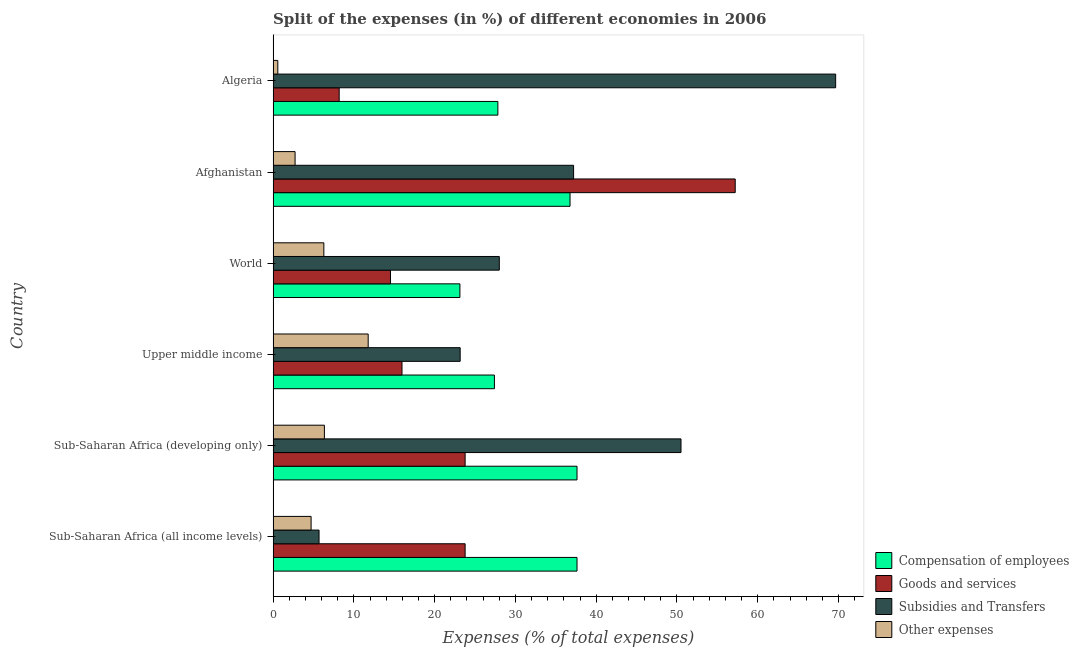How many different coloured bars are there?
Your answer should be compact. 4. How many groups of bars are there?
Your answer should be very brief. 6. Are the number of bars per tick equal to the number of legend labels?
Give a very brief answer. Yes. How many bars are there on the 6th tick from the bottom?
Your answer should be very brief. 4. What is the label of the 2nd group of bars from the top?
Offer a very short reply. Afghanistan. What is the percentage of amount spent on subsidies in Sub-Saharan Africa (all income levels)?
Give a very brief answer. 5.69. Across all countries, what is the maximum percentage of amount spent on goods and services?
Provide a succinct answer. 57.22. Across all countries, what is the minimum percentage of amount spent on compensation of employees?
Keep it short and to the point. 23.13. In which country was the percentage of amount spent on goods and services maximum?
Ensure brevity in your answer.  Afghanistan. In which country was the percentage of amount spent on goods and services minimum?
Your answer should be compact. Algeria. What is the total percentage of amount spent on other expenses in the graph?
Make the answer very short. 32.4. What is the difference between the percentage of amount spent on other expenses in Sub-Saharan Africa (developing only) and that in Upper middle income?
Your response must be concise. -5.42. What is the difference between the percentage of amount spent on subsidies in Sub-Saharan Africa (all income levels) and the percentage of amount spent on other expenses in Upper middle income?
Your response must be concise. -6.08. What is the average percentage of amount spent on compensation of employees per country?
Provide a short and direct response. 31.73. What is the difference between the percentage of amount spent on goods and services and percentage of amount spent on other expenses in Algeria?
Offer a terse response. 7.6. What is the ratio of the percentage of amount spent on goods and services in Algeria to that in World?
Your answer should be compact. 0.56. Is the percentage of amount spent on compensation of employees in Afghanistan less than that in Algeria?
Give a very brief answer. No. Is the difference between the percentage of amount spent on goods and services in Afghanistan and Upper middle income greater than the difference between the percentage of amount spent on compensation of employees in Afghanistan and Upper middle income?
Provide a succinct answer. Yes. What is the difference between the highest and the lowest percentage of amount spent on other expenses?
Ensure brevity in your answer.  11.19. In how many countries, is the percentage of amount spent on other expenses greater than the average percentage of amount spent on other expenses taken over all countries?
Provide a short and direct response. 3. Is the sum of the percentage of amount spent on goods and services in Algeria and Sub-Saharan Africa (all income levels) greater than the maximum percentage of amount spent on subsidies across all countries?
Provide a succinct answer. No. Is it the case that in every country, the sum of the percentage of amount spent on other expenses and percentage of amount spent on goods and services is greater than the sum of percentage of amount spent on compensation of employees and percentage of amount spent on subsidies?
Your answer should be compact. No. What does the 3rd bar from the top in Algeria represents?
Keep it short and to the point. Goods and services. What does the 1st bar from the bottom in Upper middle income represents?
Provide a short and direct response. Compensation of employees. Does the graph contain any zero values?
Ensure brevity in your answer.  No. Where does the legend appear in the graph?
Give a very brief answer. Bottom right. How many legend labels are there?
Make the answer very short. 4. How are the legend labels stacked?
Your response must be concise. Vertical. What is the title of the graph?
Provide a short and direct response. Split of the expenses (in %) of different economies in 2006. What is the label or title of the X-axis?
Your response must be concise. Expenses (% of total expenses). What is the Expenses (% of total expenses) of Compensation of employees in Sub-Saharan Africa (all income levels)?
Keep it short and to the point. 37.63. What is the Expenses (% of total expenses) in Goods and services in Sub-Saharan Africa (all income levels)?
Keep it short and to the point. 23.77. What is the Expenses (% of total expenses) in Subsidies and Transfers in Sub-Saharan Africa (all income levels)?
Your response must be concise. 5.69. What is the Expenses (% of total expenses) of Other expenses in Sub-Saharan Africa (all income levels)?
Your answer should be very brief. 4.7. What is the Expenses (% of total expenses) of Compensation of employees in Sub-Saharan Africa (developing only)?
Ensure brevity in your answer.  37.63. What is the Expenses (% of total expenses) in Goods and services in Sub-Saharan Africa (developing only)?
Your answer should be very brief. 23.77. What is the Expenses (% of total expenses) in Subsidies and Transfers in Sub-Saharan Africa (developing only)?
Offer a very short reply. 50.5. What is the Expenses (% of total expenses) in Other expenses in Sub-Saharan Africa (developing only)?
Provide a short and direct response. 6.35. What is the Expenses (% of total expenses) in Compensation of employees in Upper middle income?
Make the answer very short. 27.4. What is the Expenses (% of total expenses) in Goods and services in Upper middle income?
Provide a succinct answer. 15.96. What is the Expenses (% of total expenses) in Subsidies and Transfers in Upper middle income?
Your response must be concise. 23.16. What is the Expenses (% of total expenses) in Other expenses in Upper middle income?
Ensure brevity in your answer.  11.77. What is the Expenses (% of total expenses) in Compensation of employees in World?
Your answer should be compact. 23.13. What is the Expenses (% of total expenses) of Goods and services in World?
Your response must be concise. 14.53. What is the Expenses (% of total expenses) of Subsidies and Transfers in World?
Give a very brief answer. 28.01. What is the Expenses (% of total expenses) of Other expenses in World?
Offer a very short reply. 6.28. What is the Expenses (% of total expenses) of Compensation of employees in Afghanistan?
Ensure brevity in your answer.  36.76. What is the Expenses (% of total expenses) of Goods and services in Afghanistan?
Offer a very short reply. 57.22. What is the Expenses (% of total expenses) in Subsidies and Transfers in Afghanistan?
Provide a short and direct response. 37.2. What is the Expenses (% of total expenses) in Other expenses in Afghanistan?
Your answer should be very brief. 2.72. What is the Expenses (% of total expenses) in Compensation of employees in Algeria?
Make the answer very short. 27.83. What is the Expenses (% of total expenses) in Goods and services in Algeria?
Provide a succinct answer. 8.18. What is the Expenses (% of total expenses) in Subsidies and Transfers in Algeria?
Offer a very short reply. 69.65. What is the Expenses (% of total expenses) in Other expenses in Algeria?
Keep it short and to the point. 0.58. Across all countries, what is the maximum Expenses (% of total expenses) of Compensation of employees?
Offer a very short reply. 37.63. Across all countries, what is the maximum Expenses (% of total expenses) in Goods and services?
Make the answer very short. 57.22. Across all countries, what is the maximum Expenses (% of total expenses) of Subsidies and Transfers?
Ensure brevity in your answer.  69.65. Across all countries, what is the maximum Expenses (% of total expenses) of Other expenses?
Provide a succinct answer. 11.77. Across all countries, what is the minimum Expenses (% of total expenses) of Compensation of employees?
Offer a terse response. 23.13. Across all countries, what is the minimum Expenses (% of total expenses) in Goods and services?
Your answer should be compact. 8.18. Across all countries, what is the minimum Expenses (% of total expenses) in Subsidies and Transfers?
Give a very brief answer. 5.69. Across all countries, what is the minimum Expenses (% of total expenses) of Other expenses?
Make the answer very short. 0.58. What is the total Expenses (% of total expenses) of Compensation of employees in the graph?
Ensure brevity in your answer.  190.38. What is the total Expenses (% of total expenses) of Goods and services in the graph?
Offer a terse response. 143.44. What is the total Expenses (% of total expenses) of Subsidies and Transfers in the graph?
Offer a very short reply. 214.22. What is the total Expenses (% of total expenses) of Other expenses in the graph?
Provide a short and direct response. 32.4. What is the difference between the Expenses (% of total expenses) in Compensation of employees in Sub-Saharan Africa (all income levels) and that in Sub-Saharan Africa (developing only)?
Your response must be concise. 0. What is the difference between the Expenses (% of total expenses) in Subsidies and Transfers in Sub-Saharan Africa (all income levels) and that in Sub-Saharan Africa (developing only)?
Your answer should be very brief. -44.82. What is the difference between the Expenses (% of total expenses) of Other expenses in Sub-Saharan Africa (all income levels) and that in Sub-Saharan Africa (developing only)?
Your answer should be compact. -1.65. What is the difference between the Expenses (% of total expenses) in Compensation of employees in Sub-Saharan Africa (all income levels) and that in Upper middle income?
Provide a succinct answer. 10.23. What is the difference between the Expenses (% of total expenses) of Goods and services in Sub-Saharan Africa (all income levels) and that in Upper middle income?
Your response must be concise. 7.82. What is the difference between the Expenses (% of total expenses) of Subsidies and Transfers in Sub-Saharan Africa (all income levels) and that in Upper middle income?
Offer a very short reply. -17.47. What is the difference between the Expenses (% of total expenses) in Other expenses in Sub-Saharan Africa (all income levels) and that in Upper middle income?
Make the answer very short. -7.07. What is the difference between the Expenses (% of total expenses) of Compensation of employees in Sub-Saharan Africa (all income levels) and that in World?
Your answer should be compact. 14.5. What is the difference between the Expenses (% of total expenses) of Goods and services in Sub-Saharan Africa (all income levels) and that in World?
Your answer should be compact. 9.24. What is the difference between the Expenses (% of total expenses) in Subsidies and Transfers in Sub-Saharan Africa (all income levels) and that in World?
Provide a succinct answer. -22.32. What is the difference between the Expenses (% of total expenses) in Other expenses in Sub-Saharan Africa (all income levels) and that in World?
Keep it short and to the point. -1.58. What is the difference between the Expenses (% of total expenses) of Compensation of employees in Sub-Saharan Africa (all income levels) and that in Afghanistan?
Make the answer very short. 0.86. What is the difference between the Expenses (% of total expenses) of Goods and services in Sub-Saharan Africa (all income levels) and that in Afghanistan?
Your answer should be very brief. -33.44. What is the difference between the Expenses (% of total expenses) in Subsidies and Transfers in Sub-Saharan Africa (all income levels) and that in Afghanistan?
Offer a terse response. -31.52. What is the difference between the Expenses (% of total expenses) of Other expenses in Sub-Saharan Africa (all income levels) and that in Afghanistan?
Give a very brief answer. 1.98. What is the difference between the Expenses (% of total expenses) of Compensation of employees in Sub-Saharan Africa (all income levels) and that in Algeria?
Provide a succinct answer. 9.8. What is the difference between the Expenses (% of total expenses) of Goods and services in Sub-Saharan Africa (all income levels) and that in Algeria?
Give a very brief answer. 15.59. What is the difference between the Expenses (% of total expenses) of Subsidies and Transfers in Sub-Saharan Africa (all income levels) and that in Algeria?
Offer a very short reply. -63.97. What is the difference between the Expenses (% of total expenses) of Other expenses in Sub-Saharan Africa (all income levels) and that in Algeria?
Your answer should be compact. 4.12. What is the difference between the Expenses (% of total expenses) in Compensation of employees in Sub-Saharan Africa (developing only) and that in Upper middle income?
Ensure brevity in your answer.  10.23. What is the difference between the Expenses (% of total expenses) of Goods and services in Sub-Saharan Africa (developing only) and that in Upper middle income?
Your response must be concise. 7.82. What is the difference between the Expenses (% of total expenses) of Subsidies and Transfers in Sub-Saharan Africa (developing only) and that in Upper middle income?
Provide a succinct answer. 27.34. What is the difference between the Expenses (% of total expenses) in Other expenses in Sub-Saharan Africa (developing only) and that in Upper middle income?
Ensure brevity in your answer.  -5.42. What is the difference between the Expenses (% of total expenses) of Compensation of employees in Sub-Saharan Africa (developing only) and that in World?
Give a very brief answer. 14.5. What is the difference between the Expenses (% of total expenses) in Goods and services in Sub-Saharan Africa (developing only) and that in World?
Your response must be concise. 9.24. What is the difference between the Expenses (% of total expenses) of Subsidies and Transfers in Sub-Saharan Africa (developing only) and that in World?
Make the answer very short. 22.5. What is the difference between the Expenses (% of total expenses) of Other expenses in Sub-Saharan Africa (developing only) and that in World?
Your response must be concise. 0.07. What is the difference between the Expenses (% of total expenses) in Compensation of employees in Sub-Saharan Africa (developing only) and that in Afghanistan?
Your answer should be compact. 0.86. What is the difference between the Expenses (% of total expenses) in Goods and services in Sub-Saharan Africa (developing only) and that in Afghanistan?
Offer a terse response. -33.44. What is the difference between the Expenses (% of total expenses) in Subsidies and Transfers in Sub-Saharan Africa (developing only) and that in Afghanistan?
Keep it short and to the point. 13.3. What is the difference between the Expenses (% of total expenses) in Other expenses in Sub-Saharan Africa (developing only) and that in Afghanistan?
Keep it short and to the point. 3.63. What is the difference between the Expenses (% of total expenses) in Compensation of employees in Sub-Saharan Africa (developing only) and that in Algeria?
Your answer should be compact. 9.8. What is the difference between the Expenses (% of total expenses) of Goods and services in Sub-Saharan Africa (developing only) and that in Algeria?
Offer a terse response. 15.59. What is the difference between the Expenses (% of total expenses) in Subsidies and Transfers in Sub-Saharan Africa (developing only) and that in Algeria?
Your response must be concise. -19.15. What is the difference between the Expenses (% of total expenses) in Other expenses in Sub-Saharan Africa (developing only) and that in Algeria?
Your answer should be very brief. 5.77. What is the difference between the Expenses (% of total expenses) of Compensation of employees in Upper middle income and that in World?
Ensure brevity in your answer.  4.27. What is the difference between the Expenses (% of total expenses) of Goods and services in Upper middle income and that in World?
Give a very brief answer. 1.43. What is the difference between the Expenses (% of total expenses) of Subsidies and Transfers in Upper middle income and that in World?
Your answer should be very brief. -4.85. What is the difference between the Expenses (% of total expenses) in Other expenses in Upper middle income and that in World?
Provide a short and direct response. 5.49. What is the difference between the Expenses (% of total expenses) in Compensation of employees in Upper middle income and that in Afghanistan?
Provide a succinct answer. -9.36. What is the difference between the Expenses (% of total expenses) of Goods and services in Upper middle income and that in Afghanistan?
Your answer should be compact. -41.26. What is the difference between the Expenses (% of total expenses) of Subsidies and Transfers in Upper middle income and that in Afghanistan?
Provide a short and direct response. -14.04. What is the difference between the Expenses (% of total expenses) of Other expenses in Upper middle income and that in Afghanistan?
Ensure brevity in your answer.  9.05. What is the difference between the Expenses (% of total expenses) in Compensation of employees in Upper middle income and that in Algeria?
Your answer should be very brief. -0.43. What is the difference between the Expenses (% of total expenses) in Goods and services in Upper middle income and that in Algeria?
Your response must be concise. 7.78. What is the difference between the Expenses (% of total expenses) in Subsidies and Transfers in Upper middle income and that in Algeria?
Keep it short and to the point. -46.49. What is the difference between the Expenses (% of total expenses) of Other expenses in Upper middle income and that in Algeria?
Provide a succinct answer. 11.19. What is the difference between the Expenses (% of total expenses) of Compensation of employees in World and that in Afghanistan?
Ensure brevity in your answer.  -13.64. What is the difference between the Expenses (% of total expenses) in Goods and services in World and that in Afghanistan?
Make the answer very short. -42.68. What is the difference between the Expenses (% of total expenses) in Subsidies and Transfers in World and that in Afghanistan?
Your answer should be very brief. -9.2. What is the difference between the Expenses (% of total expenses) in Other expenses in World and that in Afghanistan?
Your answer should be compact. 3.56. What is the difference between the Expenses (% of total expenses) of Compensation of employees in World and that in Algeria?
Offer a very short reply. -4.7. What is the difference between the Expenses (% of total expenses) of Goods and services in World and that in Algeria?
Your answer should be compact. 6.35. What is the difference between the Expenses (% of total expenses) in Subsidies and Transfers in World and that in Algeria?
Provide a succinct answer. -41.65. What is the difference between the Expenses (% of total expenses) in Other expenses in World and that in Algeria?
Make the answer very short. 5.7. What is the difference between the Expenses (% of total expenses) in Compensation of employees in Afghanistan and that in Algeria?
Your answer should be very brief. 8.93. What is the difference between the Expenses (% of total expenses) of Goods and services in Afghanistan and that in Algeria?
Provide a short and direct response. 49.04. What is the difference between the Expenses (% of total expenses) of Subsidies and Transfers in Afghanistan and that in Algeria?
Offer a very short reply. -32.45. What is the difference between the Expenses (% of total expenses) in Other expenses in Afghanistan and that in Algeria?
Keep it short and to the point. 2.14. What is the difference between the Expenses (% of total expenses) of Compensation of employees in Sub-Saharan Africa (all income levels) and the Expenses (% of total expenses) of Goods and services in Sub-Saharan Africa (developing only)?
Your answer should be very brief. 13.85. What is the difference between the Expenses (% of total expenses) in Compensation of employees in Sub-Saharan Africa (all income levels) and the Expenses (% of total expenses) in Subsidies and Transfers in Sub-Saharan Africa (developing only)?
Provide a short and direct response. -12.88. What is the difference between the Expenses (% of total expenses) of Compensation of employees in Sub-Saharan Africa (all income levels) and the Expenses (% of total expenses) of Other expenses in Sub-Saharan Africa (developing only)?
Your answer should be very brief. 31.28. What is the difference between the Expenses (% of total expenses) of Goods and services in Sub-Saharan Africa (all income levels) and the Expenses (% of total expenses) of Subsidies and Transfers in Sub-Saharan Africa (developing only)?
Keep it short and to the point. -26.73. What is the difference between the Expenses (% of total expenses) in Goods and services in Sub-Saharan Africa (all income levels) and the Expenses (% of total expenses) in Other expenses in Sub-Saharan Africa (developing only)?
Provide a succinct answer. 17.43. What is the difference between the Expenses (% of total expenses) in Subsidies and Transfers in Sub-Saharan Africa (all income levels) and the Expenses (% of total expenses) in Other expenses in Sub-Saharan Africa (developing only)?
Your answer should be compact. -0.66. What is the difference between the Expenses (% of total expenses) of Compensation of employees in Sub-Saharan Africa (all income levels) and the Expenses (% of total expenses) of Goods and services in Upper middle income?
Offer a very short reply. 21.67. What is the difference between the Expenses (% of total expenses) of Compensation of employees in Sub-Saharan Africa (all income levels) and the Expenses (% of total expenses) of Subsidies and Transfers in Upper middle income?
Make the answer very short. 14.47. What is the difference between the Expenses (% of total expenses) of Compensation of employees in Sub-Saharan Africa (all income levels) and the Expenses (% of total expenses) of Other expenses in Upper middle income?
Your response must be concise. 25.86. What is the difference between the Expenses (% of total expenses) in Goods and services in Sub-Saharan Africa (all income levels) and the Expenses (% of total expenses) in Subsidies and Transfers in Upper middle income?
Give a very brief answer. 0.61. What is the difference between the Expenses (% of total expenses) of Goods and services in Sub-Saharan Africa (all income levels) and the Expenses (% of total expenses) of Other expenses in Upper middle income?
Give a very brief answer. 12. What is the difference between the Expenses (% of total expenses) in Subsidies and Transfers in Sub-Saharan Africa (all income levels) and the Expenses (% of total expenses) in Other expenses in Upper middle income?
Offer a very short reply. -6.08. What is the difference between the Expenses (% of total expenses) of Compensation of employees in Sub-Saharan Africa (all income levels) and the Expenses (% of total expenses) of Goods and services in World?
Make the answer very short. 23.1. What is the difference between the Expenses (% of total expenses) of Compensation of employees in Sub-Saharan Africa (all income levels) and the Expenses (% of total expenses) of Subsidies and Transfers in World?
Offer a terse response. 9.62. What is the difference between the Expenses (% of total expenses) of Compensation of employees in Sub-Saharan Africa (all income levels) and the Expenses (% of total expenses) of Other expenses in World?
Your answer should be compact. 31.35. What is the difference between the Expenses (% of total expenses) in Goods and services in Sub-Saharan Africa (all income levels) and the Expenses (% of total expenses) in Subsidies and Transfers in World?
Provide a succinct answer. -4.23. What is the difference between the Expenses (% of total expenses) of Goods and services in Sub-Saharan Africa (all income levels) and the Expenses (% of total expenses) of Other expenses in World?
Offer a very short reply. 17.49. What is the difference between the Expenses (% of total expenses) of Subsidies and Transfers in Sub-Saharan Africa (all income levels) and the Expenses (% of total expenses) of Other expenses in World?
Make the answer very short. -0.59. What is the difference between the Expenses (% of total expenses) of Compensation of employees in Sub-Saharan Africa (all income levels) and the Expenses (% of total expenses) of Goods and services in Afghanistan?
Ensure brevity in your answer.  -19.59. What is the difference between the Expenses (% of total expenses) of Compensation of employees in Sub-Saharan Africa (all income levels) and the Expenses (% of total expenses) of Subsidies and Transfers in Afghanistan?
Provide a succinct answer. 0.42. What is the difference between the Expenses (% of total expenses) in Compensation of employees in Sub-Saharan Africa (all income levels) and the Expenses (% of total expenses) in Other expenses in Afghanistan?
Your answer should be very brief. 34.91. What is the difference between the Expenses (% of total expenses) of Goods and services in Sub-Saharan Africa (all income levels) and the Expenses (% of total expenses) of Subsidies and Transfers in Afghanistan?
Provide a short and direct response. -13.43. What is the difference between the Expenses (% of total expenses) of Goods and services in Sub-Saharan Africa (all income levels) and the Expenses (% of total expenses) of Other expenses in Afghanistan?
Your answer should be compact. 21.06. What is the difference between the Expenses (% of total expenses) of Subsidies and Transfers in Sub-Saharan Africa (all income levels) and the Expenses (% of total expenses) of Other expenses in Afghanistan?
Your answer should be very brief. 2.97. What is the difference between the Expenses (% of total expenses) in Compensation of employees in Sub-Saharan Africa (all income levels) and the Expenses (% of total expenses) in Goods and services in Algeria?
Offer a terse response. 29.45. What is the difference between the Expenses (% of total expenses) in Compensation of employees in Sub-Saharan Africa (all income levels) and the Expenses (% of total expenses) in Subsidies and Transfers in Algeria?
Your answer should be compact. -32.03. What is the difference between the Expenses (% of total expenses) in Compensation of employees in Sub-Saharan Africa (all income levels) and the Expenses (% of total expenses) in Other expenses in Algeria?
Your answer should be very brief. 37.05. What is the difference between the Expenses (% of total expenses) in Goods and services in Sub-Saharan Africa (all income levels) and the Expenses (% of total expenses) in Subsidies and Transfers in Algeria?
Offer a terse response. -45.88. What is the difference between the Expenses (% of total expenses) of Goods and services in Sub-Saharan Africa (all income levels) and the Expenses (% of total expenses) of Other expenses in Algeria?
Ensure brevity in your answer.  23.19. What is the difference between the Expenses (% of total expenses) in Subsidies and Transfers in Sub-Saharan Africa (all income levels) and the Expenses (% of total expenses) in Other expenses in Algeria?
Your response must be concise. 5.11. What is the difference between the Expenses (% of total expenses) of Compensation of employees in Sub-Saharan Africa (developing only) and the Expenses (% of total expenses) of Goods and services in Upper middle income?
Provide a short and direct response. 21.67. What is the difference between the Expenses (% of total expenses) of Compensation of employees in Sub-Saharan Africa (developing only) and the Expenses (% of total expenses) of Subsidies and Transfers in Upper middle income?
Give a very brief answer. 14.47. What is the difference between the Expenses (% of total expenses) in Compensation of employees in Sub-Saharan Africa (developing only) and the Expenses (% of total expenses) in Other expenses in Upper middle income?
Offer a terse response. 25.86. What is the difference between the Expenses (% of total expenses) of Goods and services in Sub-Saharan Africa (developing only) and the Expenses (% of total expenses) of Subsidies and Transfers in Upper middle income?
Your answer should be compact. 0.61. What is the difference between the Expenses (% of total expenses) in Goods and services in Sub-Saharan Africa (developing only) and the Expenses (% of total expenses) in Other expenses in Upper middle income?
Your answer should be very brief. 12. What is the difference between the Expenses (% of total expenses) of Subsidies and Transfers in Sub-Saharan Africa (developing only) and the Expenses (% of total expenses) of Other expenses in Upper middle income?
Provide a succinct answer. 38.73. What is the difference between the Expenses (% of total expenses) in Compensation of employees in Sub-Saharan Africa (developing only) and the Expenses (% of total expenses) in Goods and services in World?
Offer a terse response. 23.1. What is the difference between the Expenses (% of total expenses) in Compensation of employees in Sub-Saharan Africa (developing only) and the Expenses (% of total expenses) in Subsidies and Transfers in World?
Offer a very short reply. 9.62. What is the difference between the Expenses (% of total expenses) in Compensation of employees in Sub-Saharan Africa (developing only) and the Expenses (% of total expenses) in Other expenses in World?
Give a very brief answer. 31.35. What is the difference between the Expenses (% of total expenses) of Goods and services in Sub-Saharan Africa (developing only) and the Expenses (% of total expenses) of Subsidies and Transfers in World?
Ensure brevity in your answer.  -4.23. What is the difference between the Expenses (% of total expenses) of Goods and services in Sub-Saharan Africa (developing only) and the Expenses (% of total expenses) of Other expenses in World?
Keep it short and to the point. 17.49. What is the difference between the Expenses (% of total expenses) of Subsidies and Transfers in Sub-Saharan Africa (developing only) and the Expenses (% of total expenses) of Other expenses in World?
Ensure brevity in your answer.  44.22. What is the difference between the Expenses (% of total expenses) of Compensation of employees in Sub-Saharan Africa (developing only) and the Expenses (% of total expenses) of Goods and services in Afghanistan?
Ensure brevity in your answer.  -19.59. What is the difference between the Expenses (% of total expenses) of Compensation of employees in Sub-Saharan Africa (developing only) and the Expenses (% of total expenses) of Subsidies and Transfers in Afghanistan?
Keep it short and to the point. 0.42. What is the difference between the Expenses (% of total expenses) of Compensation of employees in Sub-Saharan Africa (developing only) and the Expenses (% of total expenses) of Other expenses in Afghanistan?
Your answer should be compact. 34.91. What is the difference between the Expenses (% of total expenses) in Goods and services in Sub-Saharan Africa (developing only) and the Expenses (% of total expenses) in Subsidies and Transfers in Afghanistan?
Your answer should be compact. -13.43. What is the difference between the Expenses (% of total expenses) in Goods and services in Sub-Saharan Africa (developing only) and the Expenses (% of total expenses) in Other expenses in Afghanistan?
Ensure brevity in your answer.  21.06. What is the difference between the Expenses (% of total expenses) of Subsidies and Transfers in Sub-Saharan Africa (developing only) and the Expenses (% of total expenses) of Other expenses in Afghanistan?
Provide a short and direct response. 47.79. What is the difference between the Expenses (% of total expenses) of Compensation of employees in Sub-Saharan Africa (developing only) and the Expenses (% of total expenses) of Goods and services in Algeria?
Keep it short and to the point. 29.45. What is the difference between the Expenses (% of total expenses) of Compensation of employees in Sub-Saharan Africa (developing only) and the Expenses (% of total expenses) of Subsidies and Transfers in Algeria?
Offer a terse response. -32.03. What is the difference between the Expenses (% of total expenses) of Compensation of employees in Sub-Saharan Africa (developing only) and the Expenses (% of total expenses) of Other expenses in Algeria?
Provide a succinct answer. 37.05. What is the difference between the Expenses (% of total expenses) in Goods and services in Sub-Saharan Africa (developing only) and the Expenses (% of total expenses) in Subsidies and Transfers in Algeria?
Ensure brevity in your answer.  -45.88. What is the difference between the Expenses (% of total expenses) of Goods and services in Sub-Saharan Africa (developing only) and the Expenses (% of total expenses) of Other expenses in Algeria?
Your response must be concise. 23.19. What is the difference between the Expenses (% of total expenses) of Subsidies and Transfers in Sub-Saharan Africa (developing only) and the Expenses (% of total expenses) of Other expenses in Algeria?
Make the answer very short. 49.92. What is the difference between the Expenses (% of total expenses) of Compensation of employees in Upper middle income and the Expenses (% of total expenses) of Goods and services in World?
Offer a very short reply. 12.87. What is the difference between the Expenses (% of total expenses) of Compensation of employees in Upper middle income and the Expenses (% of total expenses) of Subsidies and Transfers in World?
Keep it short and to the point. -0.61. What is the difference between the Expenses (% of total expenses) in Compensation of employees in Upper middle income and the Expenses (% of total expenses) in Other expenses in World?
Make the answer very short. 21.12. What is the difference between the Expenses (% of total expenses) of Goods and services in Upper middle income and the Expenses (% of total expenses) of Subsidies and Transfers in World?
Keep it short and to the point. -12.05. What is the difference between the Expenses (% of total expenses) in Goods and services in Upper middle income and the Expenses (% of total expenses) in Other expenses in World?
Give a very brief answer. 9.68. What is the difference between the Expenses (% of total expenses) of Subsidies and Transfers in Upper middle income and the Expenses (% of total expenses) of Other expenses in World?
Provide a short and direct response. 16.88. What is the difference between the Expenses (% of total expenses) of Compensation of employees in Upper middle income and the Expenses (% of total expenses) of Goods and services in Afghanistan?
Give a very brief answer. -29.82. What is the difference between the Expenses (% of total expenses) in Compensation of employees in Upper middle income and the Expenses (% of total expenses) in Subsidies and Transfers in Afghanistan?
Ensure brevity in your answer.  -9.8. What is the difference between the Expenses (% of total expenses) in Compensation of employees in Upper middle income and the Expenses (% of total expenses) in Other expenses in Afghanistan?
Give a very brief answer. 24.68. What is the difference between the Expenses (% of total expenses) in Goods and services in Upper middle income and the Expenses (% of total expenses) in Subsidies and Transfers in Afghanistan?
Provide a short and direct response. -21.25. What is the difference between the Expenses (% of total expenses) in Goods and services in Upper middle income and the Expenses (% of total expenses) in Other expenses in Afghanistan?
Make the answer very short. 13.24. What is the difference between the Expenses (% of total expenses) in Subsidies and Transfers in Upper middle income and the Expenses (% of total expenses) in Other expenses in Afghanistan?
Provide a succinct answer. 20.44. What is the difference between the Expenses (% of total expenses) of Compensation of employees in Upper middle income and the Expenses (% of total expenses) of Goods and services in Algeria?
Your answer should be compact. 19.22. What is the difference between the Expenses (% of total expenses) in Compensation of employees in Upper middle income and the Expenses (% of total expenses) in Subsidies and Transfers in Algeria?
Make the answer very short. -42.25. What is the difference between the Expenses (% of total expenses) of Compensation of employees in Upper middle income and the Expenses (% of total expenses) of Other expenses in Algeria?
Give a very brief answer. 26.82. What is the difference between the Expenses (% of total expenses) of Goods and services in Upper middle income and the Expenses (% of total expenses) of Subsidies and Transfers in Algeria?
Provide a succinct answer. -53.7. What is the difference between the Expenses (% of total expenses) of Goods and services in Upper middle income and the Expenses (% of total expenses) of Other expenses in Algeria?
Provide a succinct answer. 15.38. What is the difference between the Expenses (% of total expenses) of Subsidies and Transfers in Upper middle income and the Expenses (% of total expenses) of Other expenses in Algeria?
Your answer should be very brief. 22.58. What is the difference between the Expenses (% of total expenses) in Compensation of employees in World and the Expenses (% of total expenses) in Goods and services in Afghanistan?
Make the answer very short. -34.09. What is the difference between the Expenses (% of total expenses) in Compensation of employees in World and the Expenses (% of total expenses) in Subsidies and Transfers in Afghanistan?
Offer a terse response. -14.08. What is the difference between the Expenses (% of total expenses) in Compensation of employees in World and the Expenses (% of total expenses) in Other expenses in Afghanistan?
Give a very brief answer. 20.41. What is the difference between the Expenses (% of total expenses) of Goods and services in World and the Expenses (% of total expenses) of Subsidies and Transfers in Afghanistan?
Ensure brevity in your answer.  -22.67. What is the difference between the Expenses (% of total expenses) of Goods and services in World and the Expenses (% of total expenses) of Other expenses in Afghanistan?
Make the answer very short. 11.81. What is the difference between the Expenses (% of total expenses) in Subsidies and Transfers in World and the Expenses (% of total expenses) in Other expenses in Afghanistan?
Your response must be concise. 25.29. What is the difference between the Expenses (% of total expenses) of Compensation of employees in World and the Expenses (% of total expenses) of Goods and services in Algeria?
Offer a very short reply. 14.95. What is the difference between the Expenses (% of total expenses) in Compensation of employees in World and the Expenses (% of total expenses) in Subsidies and Transfers in Algeria?
Your answer should be very brief. -46.53. What is the difference between the Expenses (% of total expenses) of Compensation of employees in World and the Expenses (% of total expenses) of Other expenses in Algeria?
Keep it short and to the point. 22.55. What is the difference between the Expenses (% of total expenses) in Goods and services in World and the Expenses (% of total expenses) in Subsidies and Transfers in Algeria?
Your answer should be compact. -55.12. What is the difference between the Expenses (% of total expenses) in Goods and services in World and the Expenses (% of total expenses) in Other expenses in Algeria?
Give a very brief answer. 13.95. What is the difference between the Expenses (% of total expenses) of Subsidies and Transfers in World and the Expenses (% of total expenses) of Other expenses in Algeria?
Make the answer very short. 27.43. What is the difference between the Expenses (% of total expenses) of Compensation of employees in Afghanistan and the Expenses (% of total expenses) of Goods and services in Algeria?
Keep it short and to the point. 28.58. What is the difference between the Expenses (% of total expenses) in Compensation of employees in Afghanistan and the Expenses (% of total expenses) in Subsidies and Transfers in Algeria?
Keep it short and to the point. -32.89. What is the difference between the Expenses (% of total expenses) of Compensation of employees in Afghanistan and the Expenses (% of total expenses) of Other expenses in Algeria?
Your answer should be very brief. 36.18. What is the difference between the Expenses (% of total expenses) of Goods and services in Afghanistan and the Expenses (% of total expenses) of Subsidies and Transfers in Algeria?
Provide a succinct answer. -12.44. What is the difference between the Expenses (% of total expenses) in Goods and services in Afghanistan and the Expenses (% of total expenses) in Other expenses in Algeria?
Your response must be concise. 56.63. What is the difference between the Expenses (% of total expenses) in Subsidies and Transfers in Afghanistan and the Expenses (% of total expenses) in Other expenses in Algeria?
Provide a short and direct response. 36.62. What is the average Expenses (% of total expenses) of Compensation of employees per country?
Give a very brief answer. 31.73. What is the average Expenses (% of total expenses) in Goods and services per country?
Your answer should be very brief. 23.91. What is the average Expenses (% of total expenses) in Subsidies and Transfers per country?
Offer a terse response. 35.7. What is the average Expenses (% of total expenses) in Other expenses per country?
Make the answer very short. 5.4. What is the difference between the Expenses (% of total expenses) in Compensation of employees and Expenses (% of total expenses) in Goods and services in Sub-Saharan Africa (all income levels)?
Your answer should be very brief. 13.85. What is the difference between the Expenses (% of total expenses) of Compensation of employees and Expenses (% of total expenses) of Subsidies and Transfers in Sub-Saharan Africa (all income levels)?
Provide a short and direct response. 31.94. What is the difference between the Expenses (% of total expenses) in Compensation of employees and Expenses (% of total expenses) in Other expenses in Sub-Saharan Africa (all income levels)?
Your answer should be very brief. 32.93. What is the difference between the Expenses (% of total expenses) of Goods and services and Expenses (% of total expenses) of Subsidies and Transfers in Sub-Saharan Africa (all income levels)?
Offer a terse response. 18.09. What is the difference between the Expenses (% of total expenses) in Goods and services and Expenses (% of total expenses) in Other expenses in Sub-Saharan Africa (all income levels)?
Ensure brevity in your answer.  19.07. What is the difference between the Expenses (% of total expenses) in Subsidies and Transfers and Expenses (% of total expenses) in Other expenses in Sub-Saharan Africa (all income levels)?
Your response must be concise. 0.99. What is the difference between the Expenses (% of total expenses) in Compensation of employees and Expenses (% of total expenses) in Goods and services in Sub-Saharan Africa (developing only)?
Provide a short and direct response. 13.85. What is the difference between the Expenses (% of total expenses) of Compensation of employees and Expenses (% of total expenses) of Subsidies and Transfers in Sub-Saharan Africa (developing only)?
Offer a terse response. -12.88. What is the difference between the Expenses (% of total expenses) in Compensation of employees and Expenses (% of total expenses) in Other expenses in Sub-Saharan Africa (developing only)?
Your answer should be compact. 31.28. What is the difference between the Expenses (% of total expenses) of Goods and services and Expenses (% of total expenses) of Subsidies and Transfers in Sub-Saharan Africa (developing only)?
Provide a short and direct response. -26.73. What is the difference between the Expenses (% of total expenses) in Goods and services and Expenses (% of total expenses) in Other expenses in Sub-Saharan Africa (developing only)?
Your answer should be compact. 17.43. What is the difference between the Expenses (% of total expenses) in Subsidies and Transfers and Expenses (% of total expenses) in Other expenses in Sub-Saharan Africa (developing only)?
Give a very brief answer. 44.16. What is the difference between the Expenses (% of total expenses) of Compensation of employees and Expenses (% of total expenses) of Goods and services in Upper middle income?
Your answer should be very brief. 11.44. What is the difference between the Expenses (% of total expenses) in Compensation of employees and Expenses (% of total expenses) in Subsidies and Transfers in Upper middle income?
Ensure brevity in your answer.  4.24. What is the difference between the Expenses (% of total expenses) of Compensation of employees and Expenses (% of total expenses) of Other expenses in Upper middle income?
Make the answer very short. 15.63. What is the difference between the Expenses (% of total expenses) of Goods and services and Expenses (% of total expenses) of Subsidies and Transfers in Upper middle income?
Offer a very short reply. -7.2. What is the difference between the Expenses (% of total expenses) of Goods and services and Expenses (% of total expenses) of Other expenses in Upper middle income?
Provide a succinct answer. 4.19. What is the difference between the Expenses (% of total expenses) of Subsidies and Transfers and Expenses (% of total expenses) of Other expenses in Upper middle income?
Your answer should be compact. 11.39. What is the difference between the Expenses (% of total expenses) of Compensation of employees and Expenses (% of total expenses) of Goods and services in World?
Your answer should be compact. 8.6. What is the difference between the Expenses (% of total expenses) of Compensation of employees and Expenses (% of total expenses) of Subsidies and Transfers in World?
Provide a succinct answer. -4.88. What is the difference between the Expenses (% of total expenses) in Compensation of employees and Expenses (% of total expenses) in Other expenses in World?
Your response must be concise. 16.85. What is the difference between the Expenses (% of total expenses) in Goods and services and Expenses (% of total expenses) in Subsidies and Transfers in World?
Ensure brevity in your answer.  -13.48. What is the difference between the Expenses (% of total expenses) in Goods and services and Expenses (% of total expenses) in Other expenses in World?
Your response must be concise. 8.25. What is the difference between the Expenses (% of total expenses) of Subsidies and Transfers and Expenses (% of total expenses) of Other expenses in World?
Your response must be concise. 21.73. What is the difference between the Expenses (% of total expenses) of Compensation of employees and Expenses (% of total expenses) of Goods and services in Afghanistan?
Your answer should be very brief. -20.45. What is the difference between the Expenses (% of total expenses) of Compensation of employees and Expenses (% of total expenses) of Subsidies and Transfers in Afghanistan?
Provide a succinct answer. -0.44. What is the difference between the Expenses (% of total expenses) of Compensation of employees and Expenses (% of total expenses) of Other expenses in Afghanistan?
Your answer should be compact. 34.05. What is the difference between the Expenses (% of total expenses) in Goods and services and Expenses (% of total expenses) in Subsidies and Transfers in Afghanistan?
Make the answer very short. 20.01. What is the difference between the Expenses (% of total expenses) in Goods and services and Expenses (% of total expenses) in Other expenses in Afghanistan?
Provide a succinct answer. 54.5. What is the difference between the Expenses (% of total expenses) in Subsidies and Transfers and Expenses (% of total expenses) in Other expenses in Afghanistan?
Ensure brevity in your answer.  34.49. What is the difference between the Expenses (% of total expenses) in Compensation of employees and Expenses (% of total expenses) in Goods and services in Algeria?
Offer a very short reply. 19.65. What is the difference between the Expenses (% of total expenses) in Compensation of employees and Expenses (% of total expenses) in Subsidies and Transfers in Algeria?
Offer a very short reply. -41.82. What is the difference between the Expenses (% of total expenses) in Compensation of employees and Expenses (% of total expenses) in Other expenses in Algeria?
Give a very brief answer. 27.25. What is the difference between the Expenses (% of total expenses) in Goods and services and Expenses (% of total expenses) in Subsidies and Transfers in Algeria?
Offer a very short reply. -61.47. What is the difference between the Expenses (% of total expenses) in Goods and services and Expenses (% of total expenses) in Other expenses in Algeria?
Keep it short and to the point. 7.6. What is the difference between the Expenses (% of total expenses) of Subsidies and Transfers and Expenses (% of total expenses) of Other expenses in Algeria?
Give a very brief answer. 69.07. What is the ratio of the Expenses (% of total expenses) of Subsidies and Transfers in Sub-Saharan Africa (all income levels) to that in Sub-Saharan Africa (developing only)?
Your response must be concise. 0.11. What is the ratio of the Expenses (% of total expenses) in Other expenses in Sub-Saharan Africa (all income levels) to that in Sub-Saharan Africa (developing only)?
Offer a very short reply. 0.74. What is the ratio of the Expenses (% of total expenses) in Compensation of employees in Sub-Saharan Africa (all income levels) to that in Upper middle income?
Your answer should be compact. 1.37. What is the ratio of the Expenses (% of total expenses) of Goods and services in Sub-Saharan Africa (all income levels) to that in Upper middle income?
Make the answer very short. 1.49. What is the ratio of the Expenses (% of total expenses) in Subsidies and Transfers in Sub-Saharan Africa (all income levels) to that in Upper middle income?
Your response must be concise. 0.25. What is the ratio of the Expenses (% of total expenses) of Other expenses in Sub-Saharan Africa (all income levels) to that in Upper middle income?
Keep it short and to the point. 0.4. What is the ratio of the Expenses (% of total expenses) of Compensation of employees in Sub-Saharan Africa (all income levels) to that in World?
Give a very brief answer. 1.63. What is the ratio of the Expenses (% of total expenses) in Goods and services in Sub-Saharan Africa (all income levels) to that in World?
Offer a terse response. 1.64. What is the ratio of the Expenses (% of total expenses) of Subsidies and Transfers in Sub-Saharan Africa (all income levels) to that in World?
Provide a short and direct response. 0.2. What is the ratio of the Expenses (% of total expenses) of Other expenses in Sub-Saharan Africa (all income levels) to that in World?
Give a very brief answer. 0.75. What is the ratio of the Expenses (% of total expenses) of Compensation of employees in Sub-Saharan Africa (all income levels) to that in Afghanistan?
Your answer should be compact. 1.02. What is the ratio of the Expenses (% of total expenses) of Goods and services in Sub-Saharan Africa (all income levels) to that in Afghanistan?
Offer a very short reply. 0.42. What is the ratio of the Expenses (% of total expenses) of Subsidies and Transfers in Sub-Saharan Africa (all income levels) to that in Afghanistan?
Give a very brief answer. 0.15. What is the ratio of the Expenses (% of total expenses) in Other expenses in Sub-Saharan Africa (all income levels) to that in Afghanistan?
Make the answer very short. 1.73. What is the ratio of the Expenses (% of total expenses) in Compensation of employees in Sub-Saharan Africa (all income levels) to that in Algeria?
Your answer should be compact. 1.35. What is the ratio of the Expenses (% of total expenses) of Goods and services in Sub-Saharan Africa (all income levels) to that in Algeria?
Keep it short and to the point. 2.91. What is the ratio of the Expenses (% of total expenses) in Subsidies and Transfers in Sub-Saharan Africa (all income levels) to that in Algeria?
Provide a short and direct response. 0.08. What is the ratio of the Expenses (% of total expenses) of Other expenses in Sub-Saharan Africa (all income levels) to that in Algeria?
Your answer should be compact. 8.08. What is the ratio of the Expenses (% of total expenses) of Compensation of employees in Sub-Saharan Africa (developing only) to that in Upper middle income?
Offer a very short reply. 1.37. What is the ratio of the Expenses (% of total expenses) in Goods and services in Sub-Saharan Africa (developing only) to that in Upper middle income?
Your answer should be very brief. 1.49. What is the ratio of the Expenses (% of total expenses) in Subsidies and Transfers in Sub-Saharan Africa (developing only) to that in Upper middle income?
Provide a short and direct response. 2.18. What is the ratio of the Expenses (% of total expenses) of Other expenses in Sub-Saharan Africa (developing only) to that in Upper middle income?
Offer a very short reply. 0.54. What is the ratio of the Expenses (% of total expenses) in Compensation of employees in Sub-Saharan Africa (developing only) to that in World?
Offer a very short reply. 1.63. What is the ratio of the Expenses (% of total expenses) of Goods and services in Sub-Saharan Africa (developing only) to that in World?
Ensure brevity in your answer.  1.64. What is the ratio of the Expenses (% of total expenses) of Subsidies and Transfers in Sub-Saharan Africa (developing only) to that in World?
Make the answer very short. 1.8. What is the ratio of the Expenses (% of total expenses) of Other expenses in Sub-Saharan Africa (developing only) to that in World?
Your response must be concise. 1.01. What is the ratio of the Expenses (% of total expenses) of Compensation of employees in Sub-Saharan Africa (developing only) to that in Afghanistan?
Your answer should be very brief. 1.02. What is the ratio of the Expenses (% of total expenses) of Goods and services in Sub-Saharan Africa (developing only) to that in Afghanistan?
Your answer should be compact. 0.42. What is the ratio of the Expenses (% of total expenses) of Subsidies and Transfers in Sub-Saharan Africa (developing only) to that in Afghanistan?
Offer a terse response. 1.36. What is the ratio of the Expenses (% of total expenses) in Other expenses in Sub-Saharan Africa (developing only) to that in Afghanistan?
Offer a terse response. 2.34. What is the ratio of the Expenses (% of total expenses) of Compensation of employees in Sub-Saharan Africa (developing only) to that in Algeria?
Ensure brevity in your answer.  1.35. What is the ratio of the Expenses (% of total expenses) of Goods and services in Sub-Saharan Africa (developing only) to that in Algeria?
Provide a succinct answer. 2.91. What is the ratio of the Expenses (% of total expenses) in Subsidies and Transfers in Sub-Saharan Africa (developing only) to that in Algeria?
Your answer should be very brief. 0.73. What is the ratio of the Expenses (% of total expenses) in Other expenses in Sub-Saharan Africa (developing only) to that in Algeria?
Your answer should be very brief. 10.91. What is the ratio of the Expenses (% of total expenses) of Compensation of employees in Upper middle income to that in World?
Provide a succinct answer. 1.18. What is the ratio of the Expenses (% of total expenses) in Goods and services in Upper middle income to that in World?
Keep it short and to the point. 1.1. What is the ratio of the Expenses (% of total expenses) of Subsidies and Transfers in Upper middle income to that in World?
Keep it short and to the point. 0.83. What is the ratio of the Expenses (% of total expenses) in Other expenses in Upper middle income to that in World?
Provide a short and direct response. 1.87. What is the ratio of the Expenses (% of total expenses) of Compensation of employees in Upper middle income to that in Afghanistan?
Your answer should be compact. 0.75. What is the ratio of the Expenses (% of total expenses) of Goods and services in Upper middle income to that in Afghanistan?
Ensure brevity in your answer.  0.28. What is the ratio of the Expenses (% of total expenses) in Subsidies and Transfers in Upper middle income to that in Afghanistan?
Offer a terse response. 0.62. What is the ratio of the Expenses (% of total expenses) of Other expenses in Upper middle income to that in Afghanistan?
Offer a very short reply. 4.33. What is the ratio of the Expenses (% of total expenses) of Compensation of employees in Upper middle income to that in Algeria?
Provide a short and direct response. 0.98. What is the ratio of the Expenses (% of total expenses) of Goods and services in Upper middle income to that in Algeria?
Offer a terse response. 1.95. What is the ratio of the Expenses (% of total expenses) of Subsidies and Transfers in Upper middle income to that in Algeria?
Your response must be concise. 0.33. What is the ratio of the Expenses (% of total expenses) of Other expenses in Upper middle income to that in Algeria?
Your response must be concise. 20.23. What is the ratio of the Expenses (% of total expenses) in Compensation of employees in World to that in Afghanistan?
Ensure brevity in your answer.  0.63. What is the ratio of the Expenses (% of total expenses) in Goods and services in World to that in Afghanistan?
Offer a very short reply. 0.25. What is the ratio of the Expenses (% of total expenses) in Subsidies and Transfers in World to that in Afghanistan?
Your answer should be compact. 0.75. What is the ratio of the Expenses (% of total expenses) in Other expenses in World to that in Afghanistan?
Your answer should be compact. 2.31. What is the ratio of the Expenses (% of total expenses) of Compensation of employees in World to that in Algeria?
Ensure brevity in your answer.  0.83. What is the ratio of the Expenses (% of total expenses) in Goods and services in World to that in Algeria?
Ensure brevity in your answer.  1.78. What is the ratio of the Expenses (% of total expenses) in Subsidies and Transfers in World to that in Algeria?
Your answer should be very brief. 0.4. What is the ratio of the Expenses (% of total expenses) of Other expenses in World to that in Algeria?
Make the answer very short. 10.79. What is the ratio of the Expenses (% of total expenses) of Compensation of employees in Afghanistan to that in Algeria?
Provide a succinct answer. 1.32. What is the ratio of the Expenses (% of total expenses) of Goods and services in Afghanistan to that in Algeria?
Your response must be concise. 6.99. What is the ratio of the Expenses (% of total expenses) of Subsidies and Transfers in Afghanistan to that in Algeria?
Your answer should be very brief. 0.53. What is the ratio of the Expenses (% of total expenses) in Other expenses in Afghanistan to that in Algeria?
Offer a very short reply. 4.67. What is the difference between the highest and the second highest Expenses (% of total expenses) of Compensation of employees?
Give a very brief answer. 0. What is the difference between the highest and the second highest Expenses (% of total expenses) of Goods and services?
Provide a short and direct response. 33.44. What is the difference between the highest and the second highest Expenses (% of total expenses) of Subsidies and Transfers?
Provide a short and direct response. 19.15. What is the difference between the highest and the second highest Expenses (% of total expenses) in Other expenses?
Provide a succinct answer. 5.42. What is the difference between the highest and the lowest Expenses (% of total expenses) of Compensation of employees?
Make the answer very short. 14.5. What is the difference between the highest and the lowest Expenses (% of total expenses) of Goods and services?
Your answer should be very brief. 49.04. What is the difference between the highest and the lowest Expenses (% of total expenses) of Subsidies and Transfers?
Provide a succinct answer. 63.97. What is the difference between the highest and the lowest Expenses (% of total expenses) of Other expenses?
Your answer should be very brief. 11.19. 